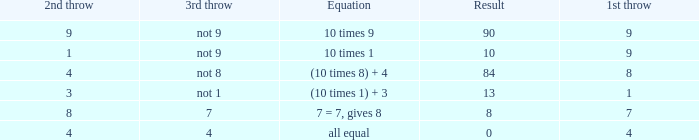What is the result when the 3rd throw is not 8? 84.0. 